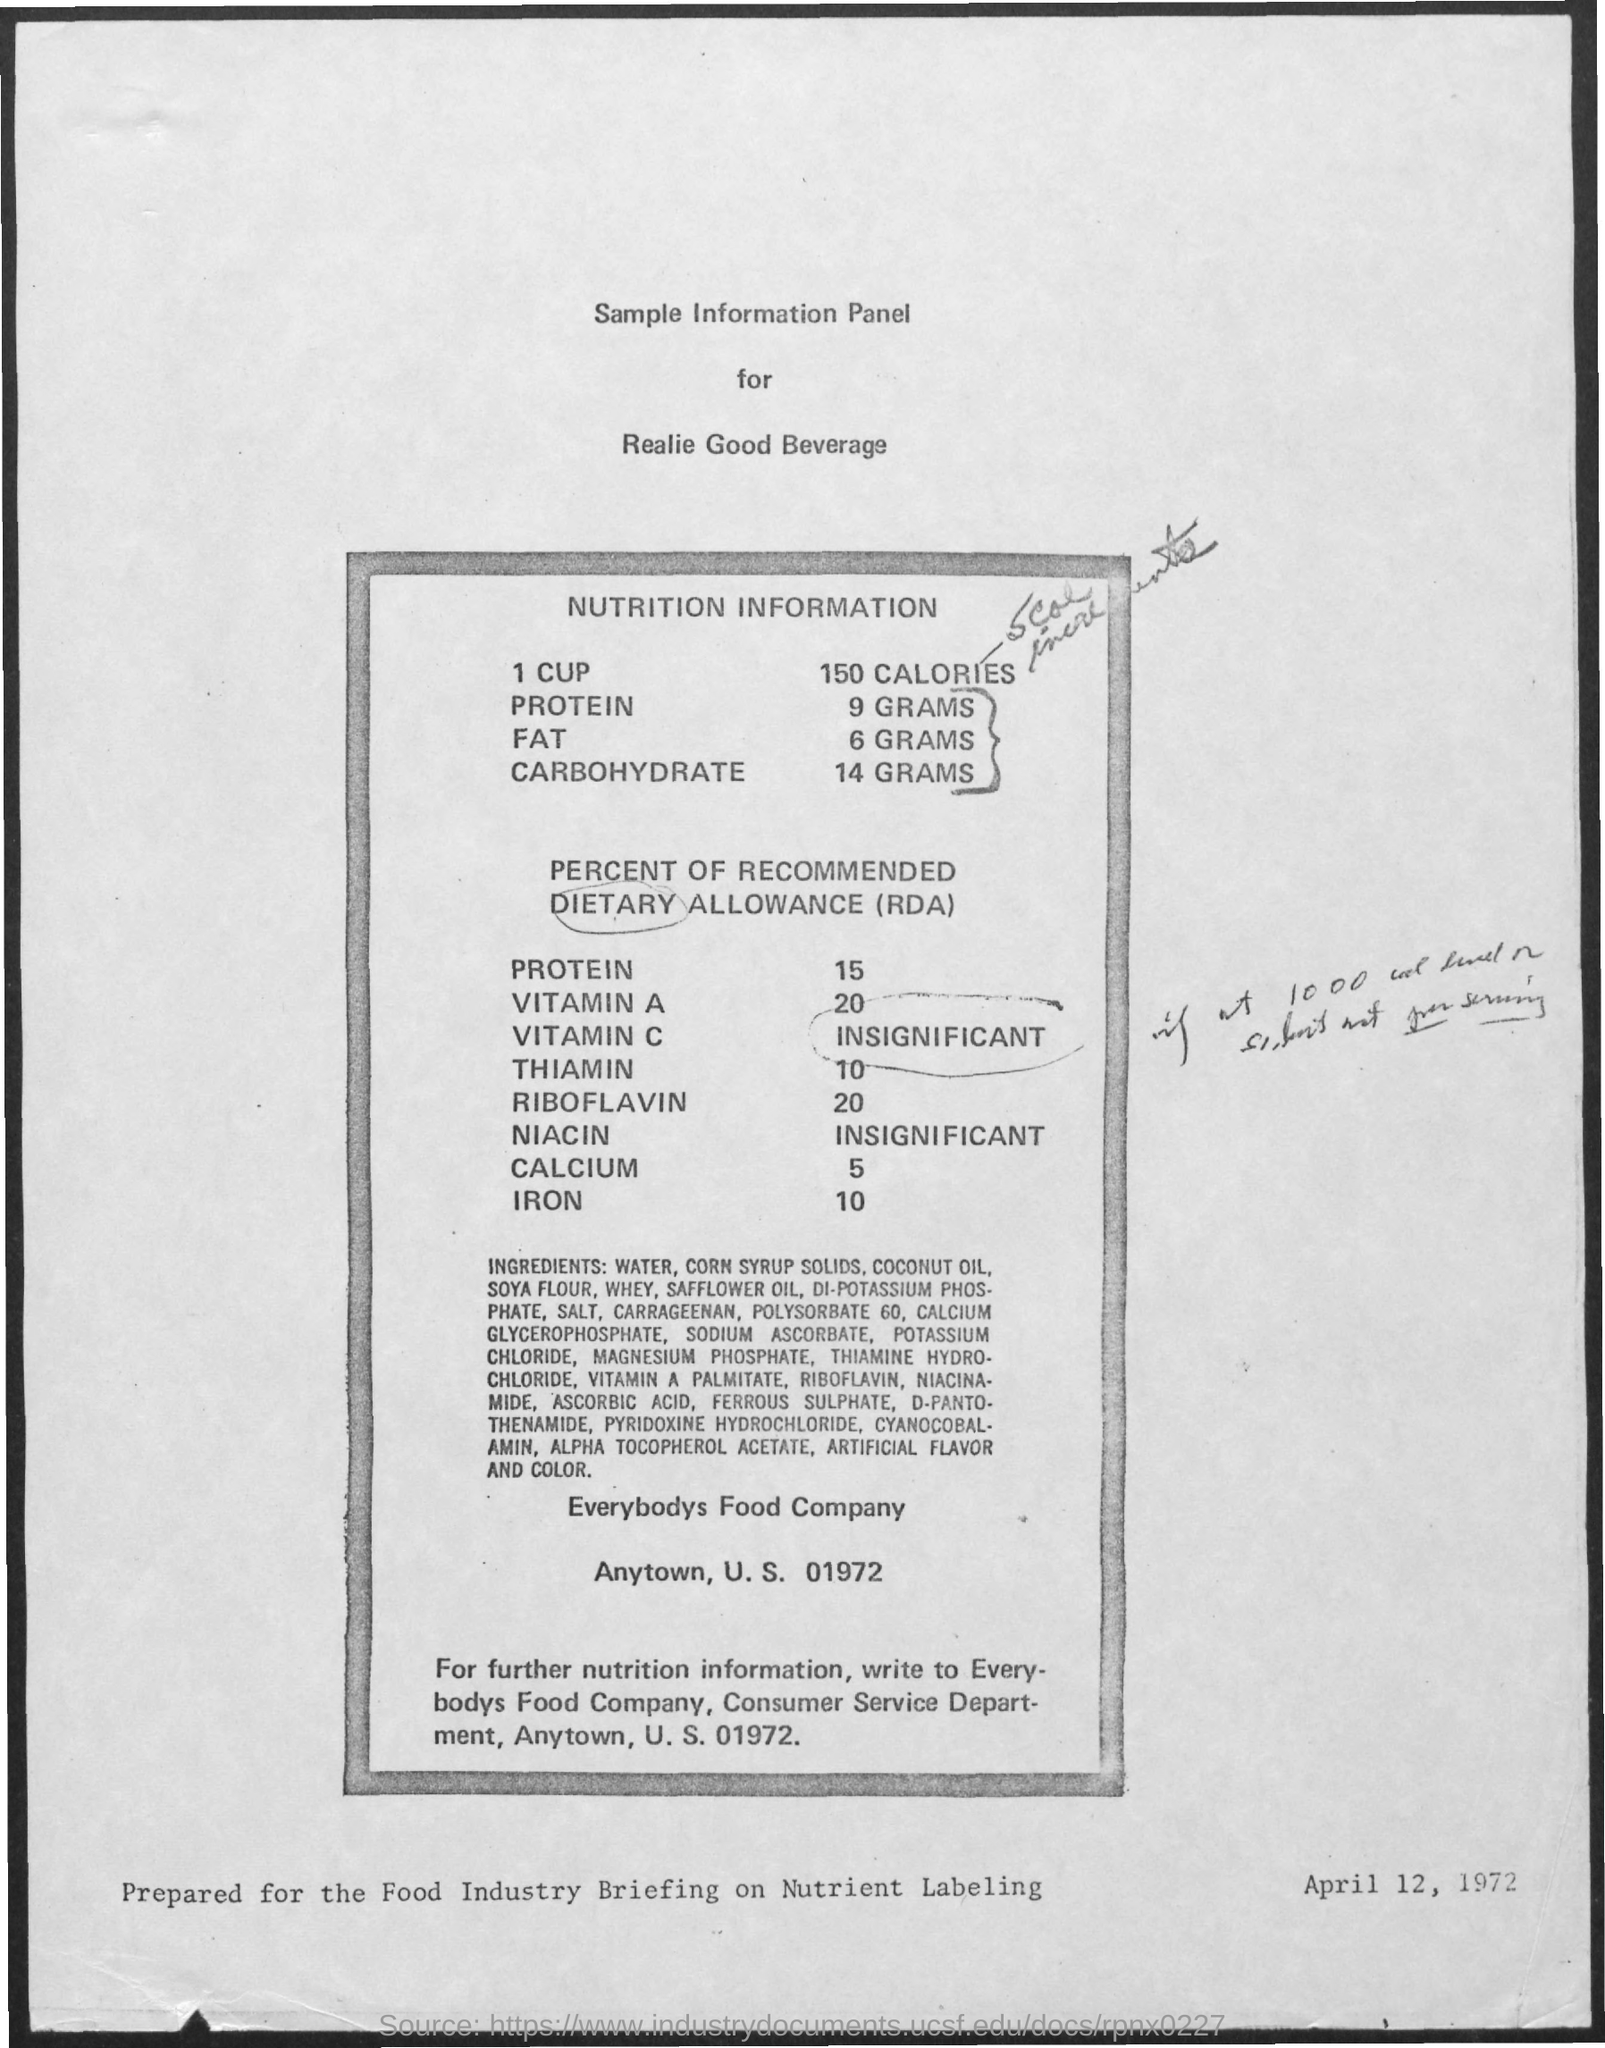How many Calories in 1 Cup?
Provide a succinct answer. 150 Calories. How much Protein?
Provide a short and direct response. 9 Grams. How much Fat?
Make the answer very short. 6 Grams. How much Carbohydrate?
Make the answer very short. 14 Grams. 